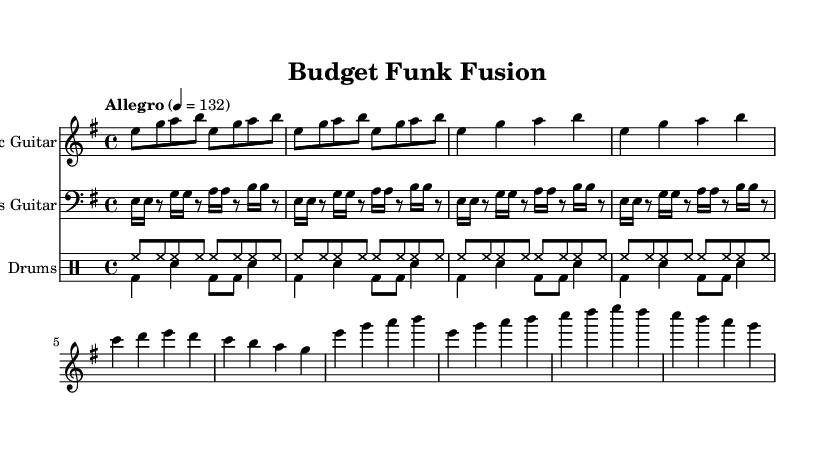What is the key signature of this music? The key signature indicates E minor, which has one sharp (F#). This can be identified by the key signature symbol at the beginning of the staff.
Answer: E minor What is the time signature of this music? The time signature shows 4/4, which means there are four beats in a measure and the quarter note gets one beat. This is placed at the beginning of the staff next to the key signature.
Answer: 4/4 What is the tempo marking of this music? The tempo marking indicates "Allegro" with a quarter note = 132, specifying the speed at which the piece should be played. This is found at the top of the score, under the header.
Answer: Allegro 4 = 132 How many instruments are featured in the score? The score features three instruments: Electric Guitar, Bass Guitar, and Drums. This is evident as each staff in the score is labeled with the respective instrument names.
Answer: Three What is the primary rhythm style used by the bass guitar? The primary rhythm style featured in the bass guitar part is slap bass, which can be recognized by the rhythmic pattern and the fast-paced notes written as sixteenth notes.
Answer: Slap bass In what section does the chorus occur? The chorus occurs after the verse; it comprises repeated sections that build upon the foundational elements. We recognize its structure by the recurrence of musical phrases distinct from those in the verse.
Answer: After the verse What is the dynamic level typically used in a funk-rock fusion piece like this? Funk-rock fusion pieces like this often feature energetic dynamics, characterized by strong accentuations and lively rhythms. Although dynamics are not explicitly notated here, the feel of the rhythm suggests a high-energy approach.
Answer: Energetic 